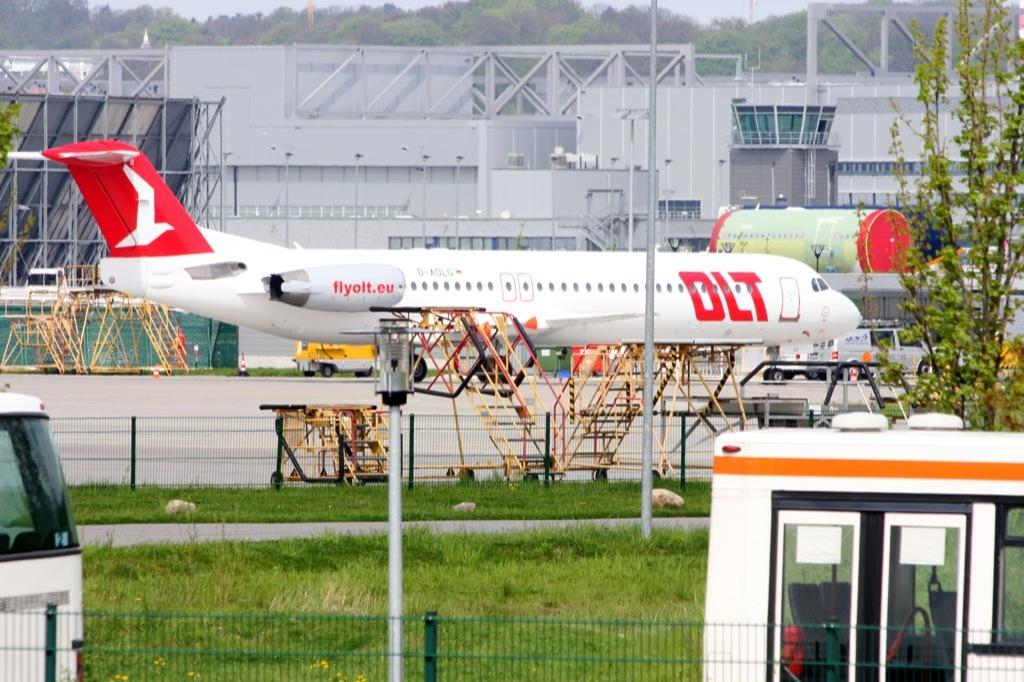What airline is about to take off?
Your answer should be compact. Dlt. What is the webesite on the engine?
Offer a terse response. Flyolt.eu. 